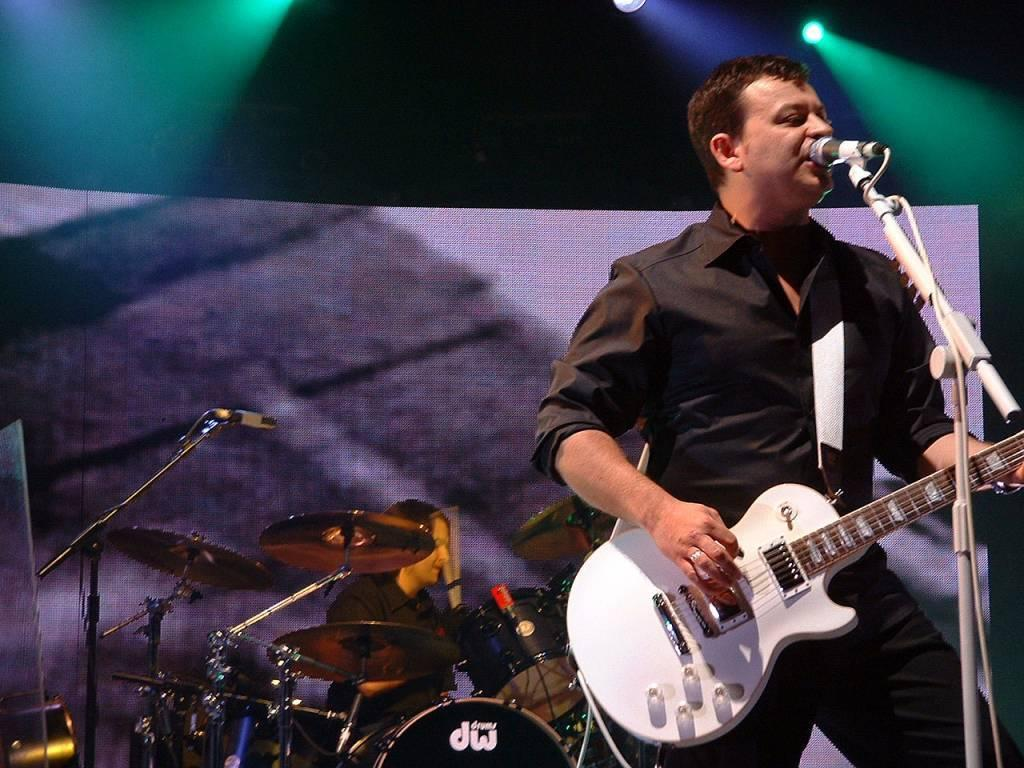What is the man in the foreground of the image holding? The man in the foreground of the image is holding a guitar. What is the other man in the image doing? The other man is sitting next to a drum set in the background of the image. What objects might be used for amplifying sound in the image? Microphones are visible in the image. What type of comfort can be seen being distributed to the audience in the image? There is no indication of comfort or distribution to an audience in the image. 